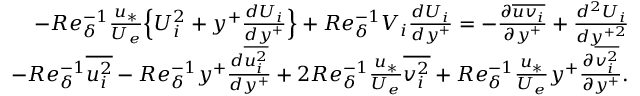<formula> <loc_0><loc_0><loc_500><loc_500>\begin{array} { r } { - R e _ { \delta } ^ { - 1 } \frac { u _ { * } } { U _ { e } } \left \{ U _ { i } ^ { 2 } + y ^ { + } \frac { d U _ { i } } { d y ^ { + } } \right \} + R e _ { \delta } ^ { - 1 } V _ { i } \frac { d U _ { i } } { d y ^ { + } } = - \frac { \partial \overline { { u v _ { i } } } } { \partial y ^ { + } } + \frac { d ^ { 2 } U _ { i } } { d y ^ { + 2 } } } \\ { - R e _ { \delta } ^ { - 1 } \overline { { u _ { i } ^ { 2 } } } - R e _ { \delta } ^ { - 1 } y ^ { + } \frac { d \overline { { u _ { i } ^ { 2 } } } } { d y ^ { + } } + 2 R e _ { \delta } ^ { - 1 } \frac { u _ { * } } { U _ { e } } \overline { { v _ { i } ^ { 2 } } } + R e _ { \delta } ^ { - 1 } \frac { u _ { * } } { U _ { e } } y ^ { + } \frac { \partial \overline { { v _ { i } ^ { 2 } } } } { \partial y ^ { + } } . } \end{array}</formula> 